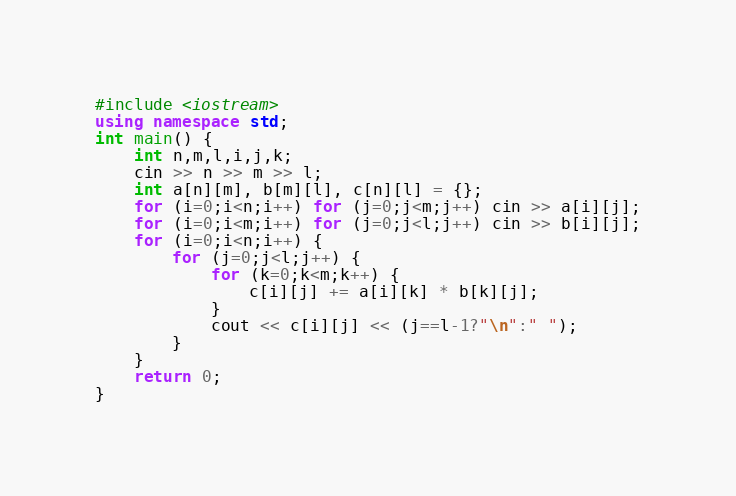Convert code to text. <code><loc_0><loc_0><loc_500><loc_500><_C++_>#include <iostream>
using namespace std;
int main() {
    int n,m,l,i,j,k;
    cin >> n >> m >> l;
    int a[n][m], b[m][l], c[n][l] = {};
    for (i=0;i<n;i++) for (j=0;j<m;j++) cin >> a[i][j];
    for (i=0;i<m;i++) for (j=0;j<l;j++) cin >> b[i][j];
    for (i=0;i<n;i++) {
        for (j=0;j<l;j++) {
            for (k=0;k<m;k++) {
                c[i][j] += a[i][k] * b[k][j];
            }
            cout << c[i][j] << (j==l-1?"\n":" ");
        }
    }
    return 0;
}</code> 